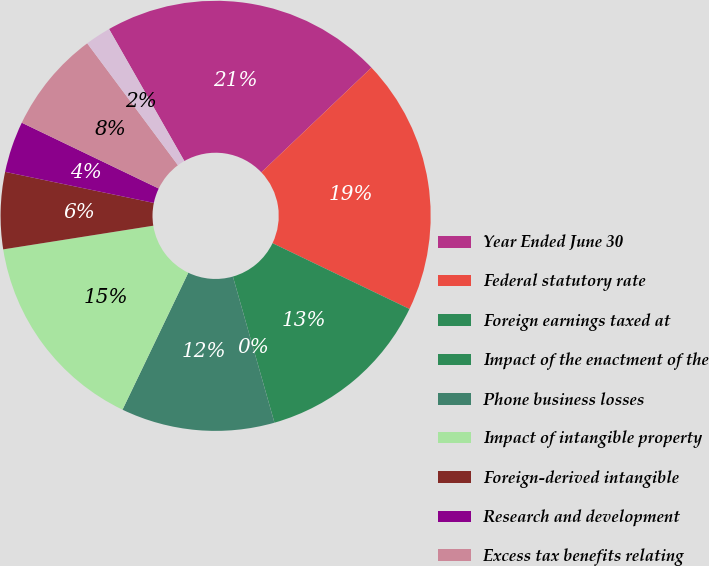Convert chart. <chart><loc_0><loc_0><loc_500><loc_500><pie_chart><fcel>Year Ended June 30<fcel>Federal statutory rate<fcel>Foreign earnings taxed at<fcel>Impact of the enactment of the<fcel>Phone business losses<fcel>Impact of intangible property<fcel>Foreign-derived intangible<fcel>Research and development<fcel>Excess tax benefits relating<fcel>Interest net<nl><fcel>21.15%<fcel>19.23%<fcel>13.46%<fcel>0.0%<fcel>11.54%<fcel>15.38%<fcel>5.77%<fcel>3.85%<fcel>7.69%<fcel>1.93%<nl></chart> 